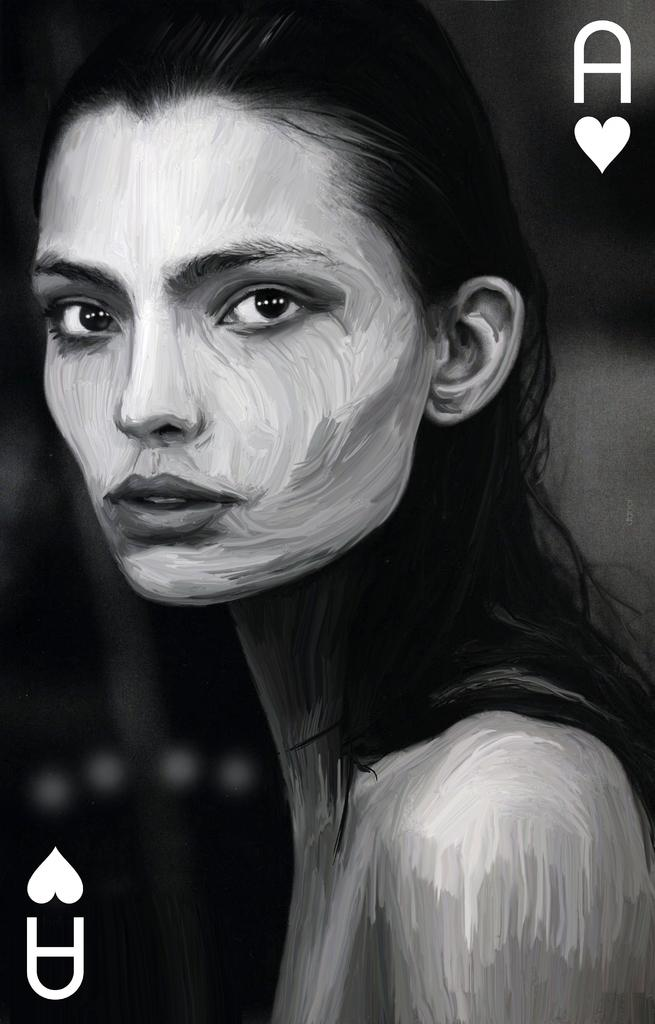What is the color scheme of the image? The image is black and white. Who or what is the main subject in the image? There is a woman in the image. What can be seen in the top right corner of the image? There is a letter in the top right corner of the image. What is located in the bottom left corner of the image? There is a symbol in the bottom left corner of the image. What type of wine is being poured into the glass in the image? There is no wine or glass present in the image; it is a black and white image featuring a woman, a letter, and a symbol. 